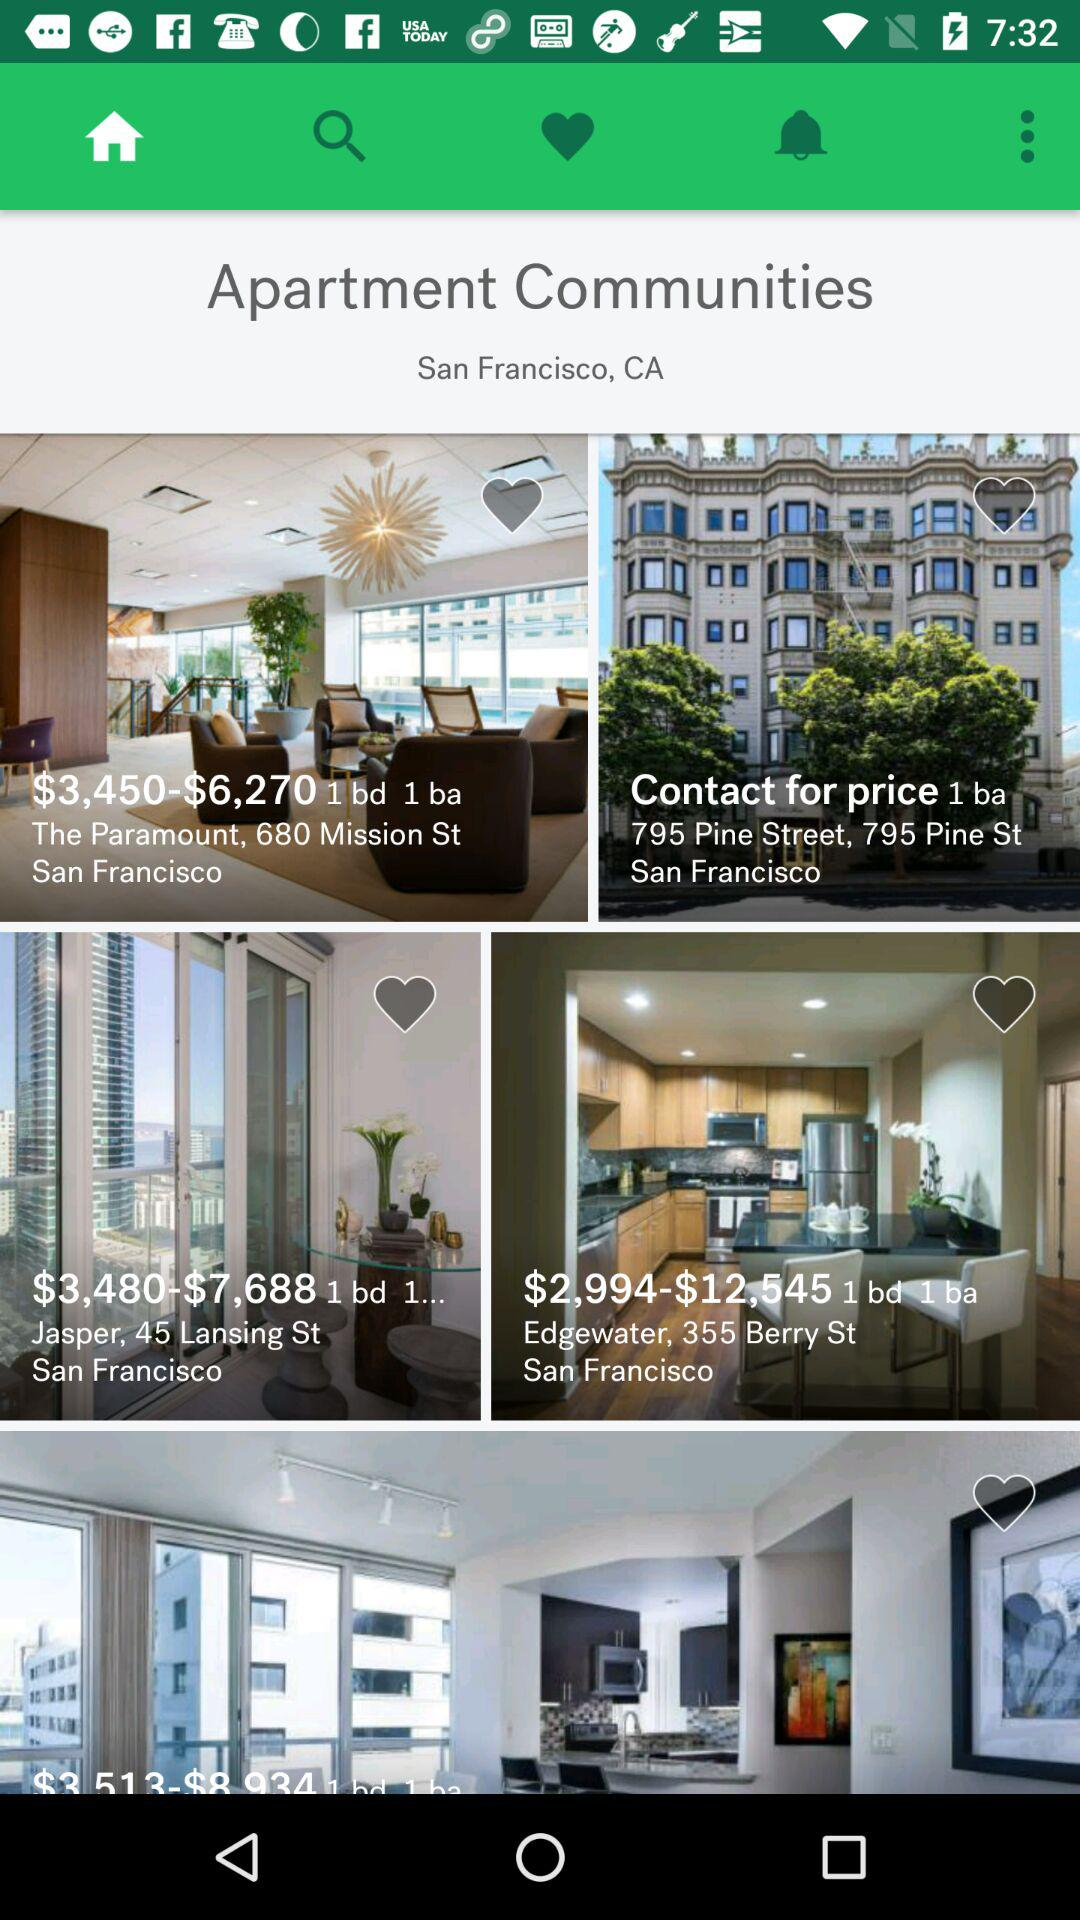What is the location of apartment communities? The location is San Francisco, CA. 